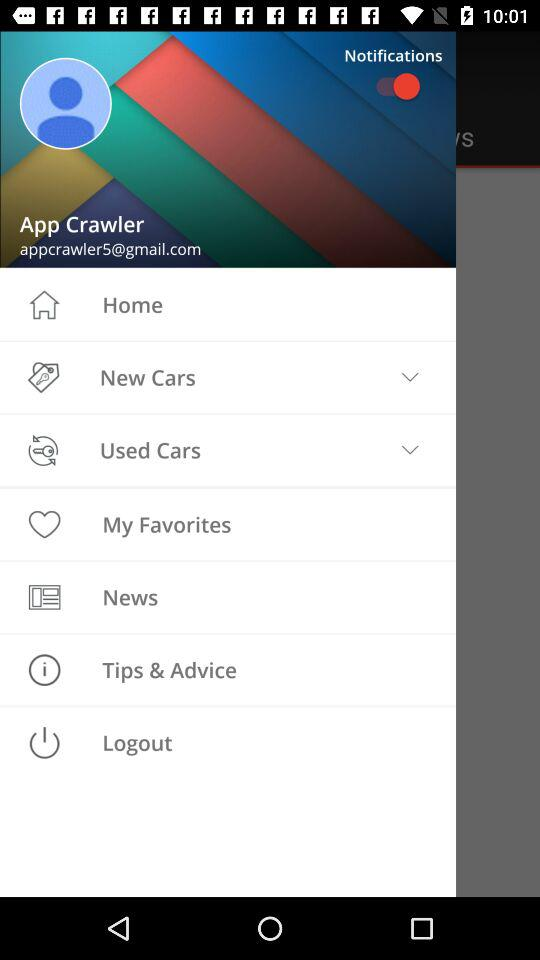What is the profile name? The profile name is App Crawler. 